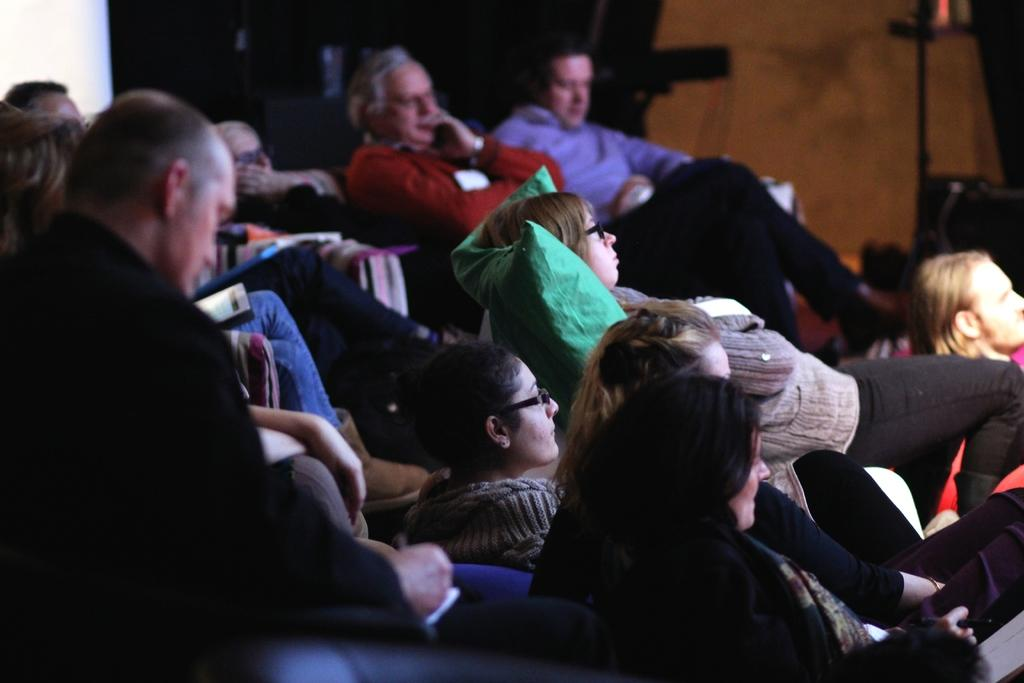How many people are in the image? There is a group of people in the image. What are the people doing in the image? The people are sitting on chairs. Can you describe the background of the image? The provided facts do not give specific details about the background, but we know there are objects visible in it. What type of pocket can be seen on the apparel of the people in the image? There is no mention of apparel or pockets in the provided facts, so we cannot determine if there are any pockets present on the people's clothing in the image. 